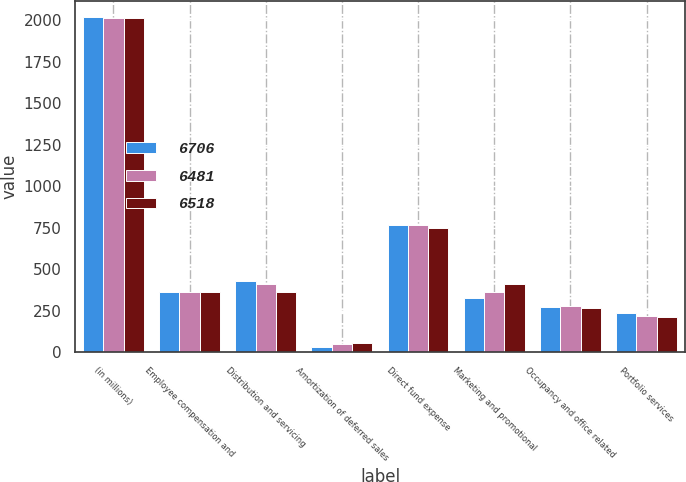Convert chart to OTSL. <chart><loc_0><loc_0><loc_500><loc_500><stacked_bar_chart><ecel><fcel>(in millions)<fcel>Employee compensation and<fcel>Distribution and servicing<fcel>Amortization of deferred sales<fcel>Direct fund expense<fcel>Marketing and promotional<fcel>Occupancy and office related<fcel>Portfolio services<nl><fcel>6706<fcel>2016<fcel>364<fcel>429<fcel>34<fcel>766<fcel>325<fcel>272<fcel>234<nl><fcel>6481<fcel>2015<fcel>364<fcel>409<fcel>48<fcel>767<fcel>365<fcel>280<fcel>221<nl><fcel>6518<fcel>2014<fcel>364<fcel>364<fcel>56<fcel>748<fcel>413<fcel>267<fcel>215<nl></chart> 